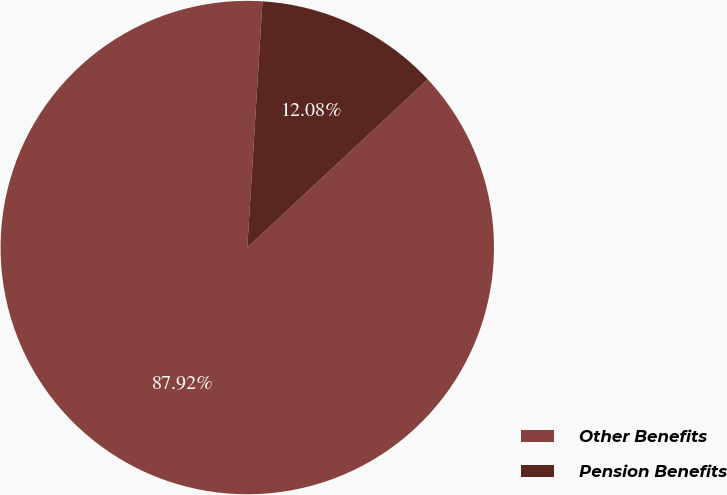<chart> <loc_0><loc_0><loc_500><loc_500><pie_chart><fcel>Other Benefits<fcel>Pension Benefits<nl><fcel>87.92%<fcel>12.08%<nl></chart> 